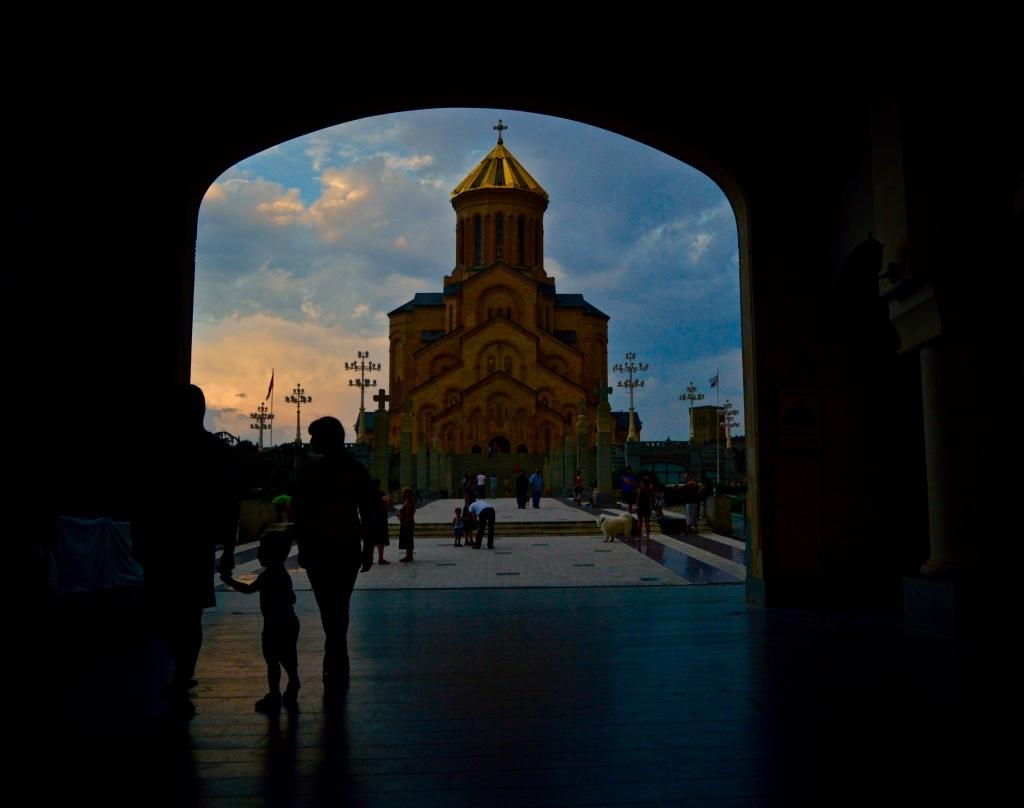At what time of day was the image taken? The image was taken during the evening. What is the main subject in the center of the image? There is a church in the center of the image. What structures are present to provide illumination in the image? There are light poles visible in the image. What are the people in the image doing? There are people on the floor in the image. What can be seen in the sky in the image? The sky is visible in the image, and there are clouds present. What type of brass material is being used to hold the tin together in the image? There is no brass or tin present in the image, and therefore no such material is being used to hold anything together. 